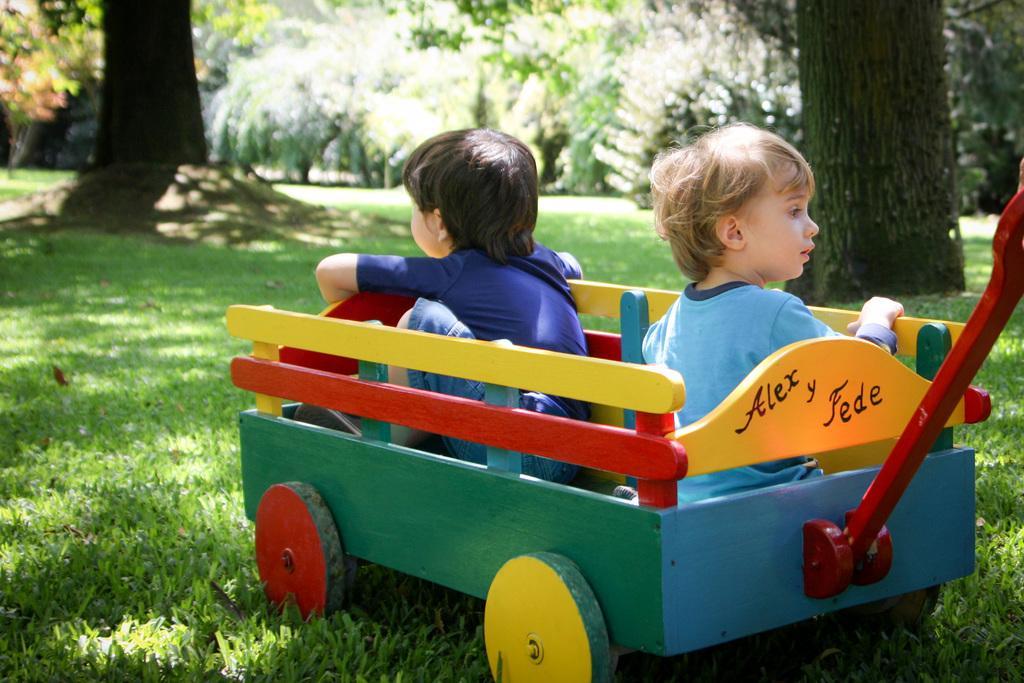How would you summarize this image in a sentence or two? This picture shows a wooden trolley and we see couple of kids seated in it. It is green, yellow, blue and red in color and we see grass on the ground and trees. 